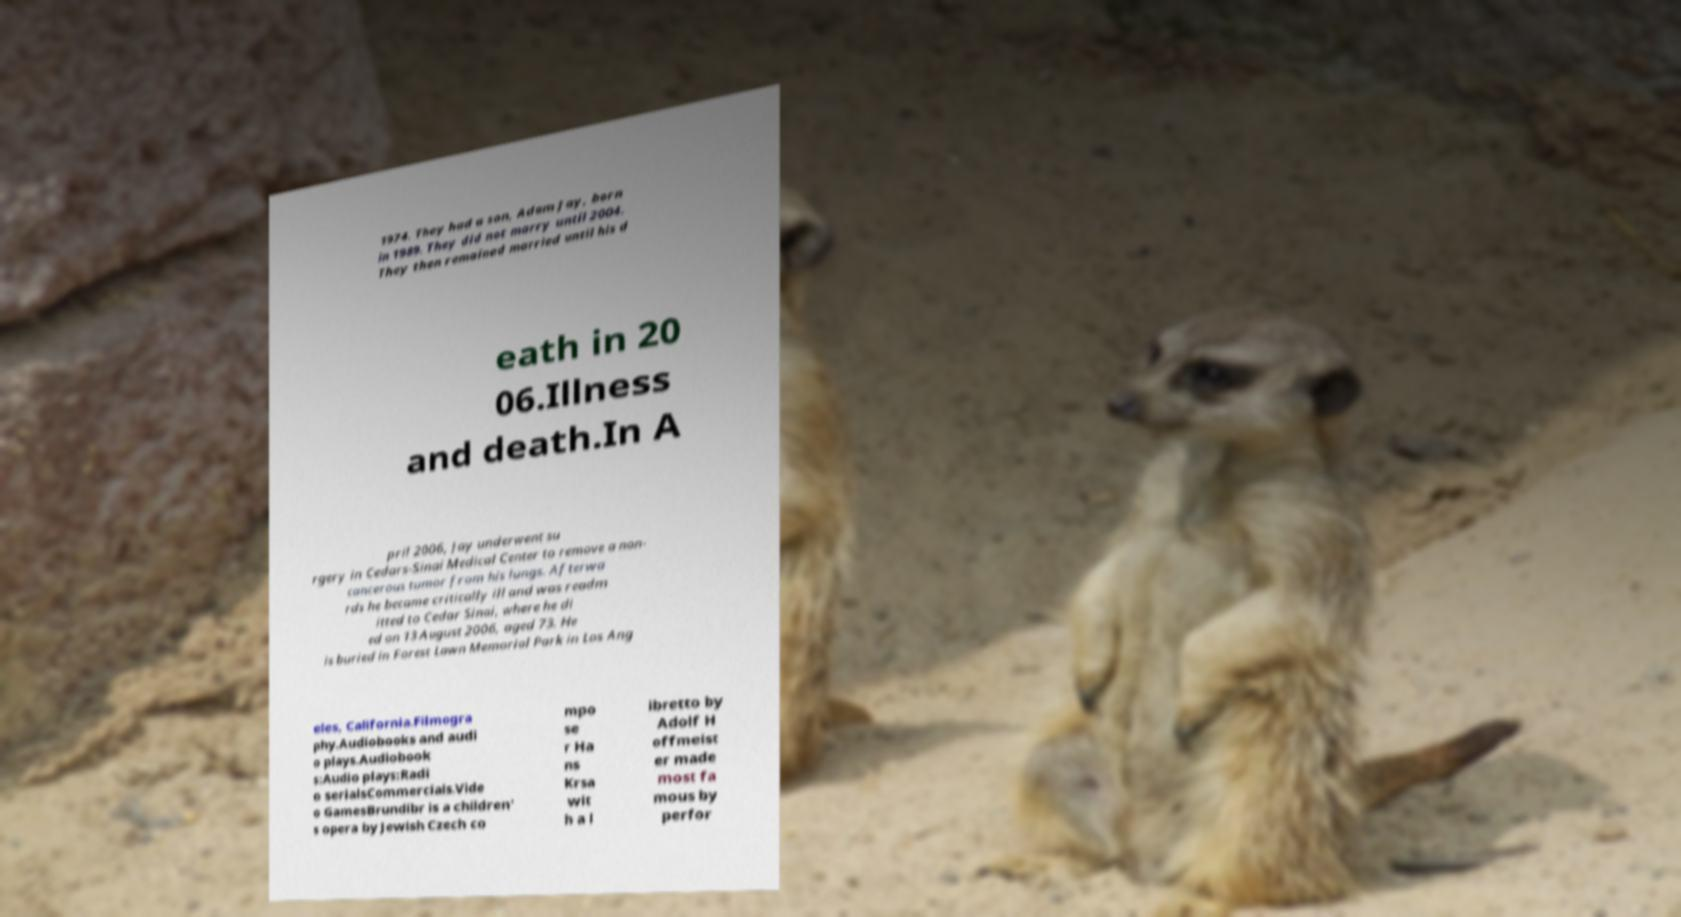There's text embedded in this image that I need extracted. Can you transcribe it verbatim? 1974. They had a son, Adam Jay, born in 1989. They did not marry until 2004. They then remained married until his d eath in 20 06.Illness and death.In A pril 2006, Jay underwent su rgery in Cedars-Sinai Medical Center to remove a non- cancerous tumor from his lungs. Afterwa rds he became critically ill and was readm itted to Cedar Sinai, where he di ed on 13 August 2006, aged 73. He is buried in Forest Lawn Memorial Park in Los Ang eles, California.Filmogra phy.Audiobooks and audi o plays.Audiobook s:Audio plays:Radi o serialsCommercials.Vide o GamesBrundibr is a children' s opera by Jewish Czech co mpo se r Ha ns Krsa wit h a l ibretto by Adolf H offmeist er made most fa mous by perfor 